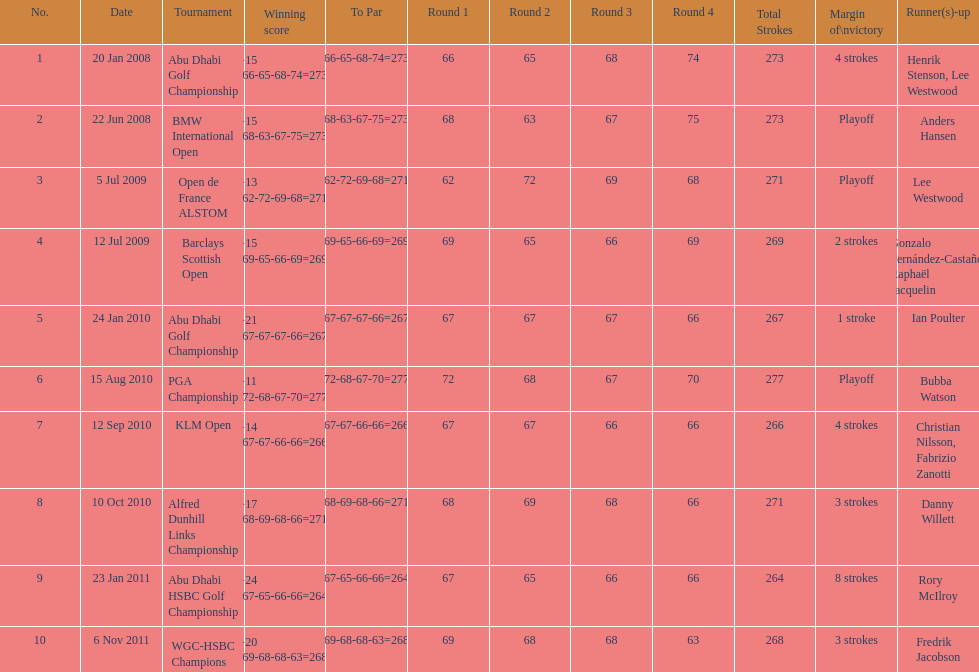How many total tournaments has he won? 10. 